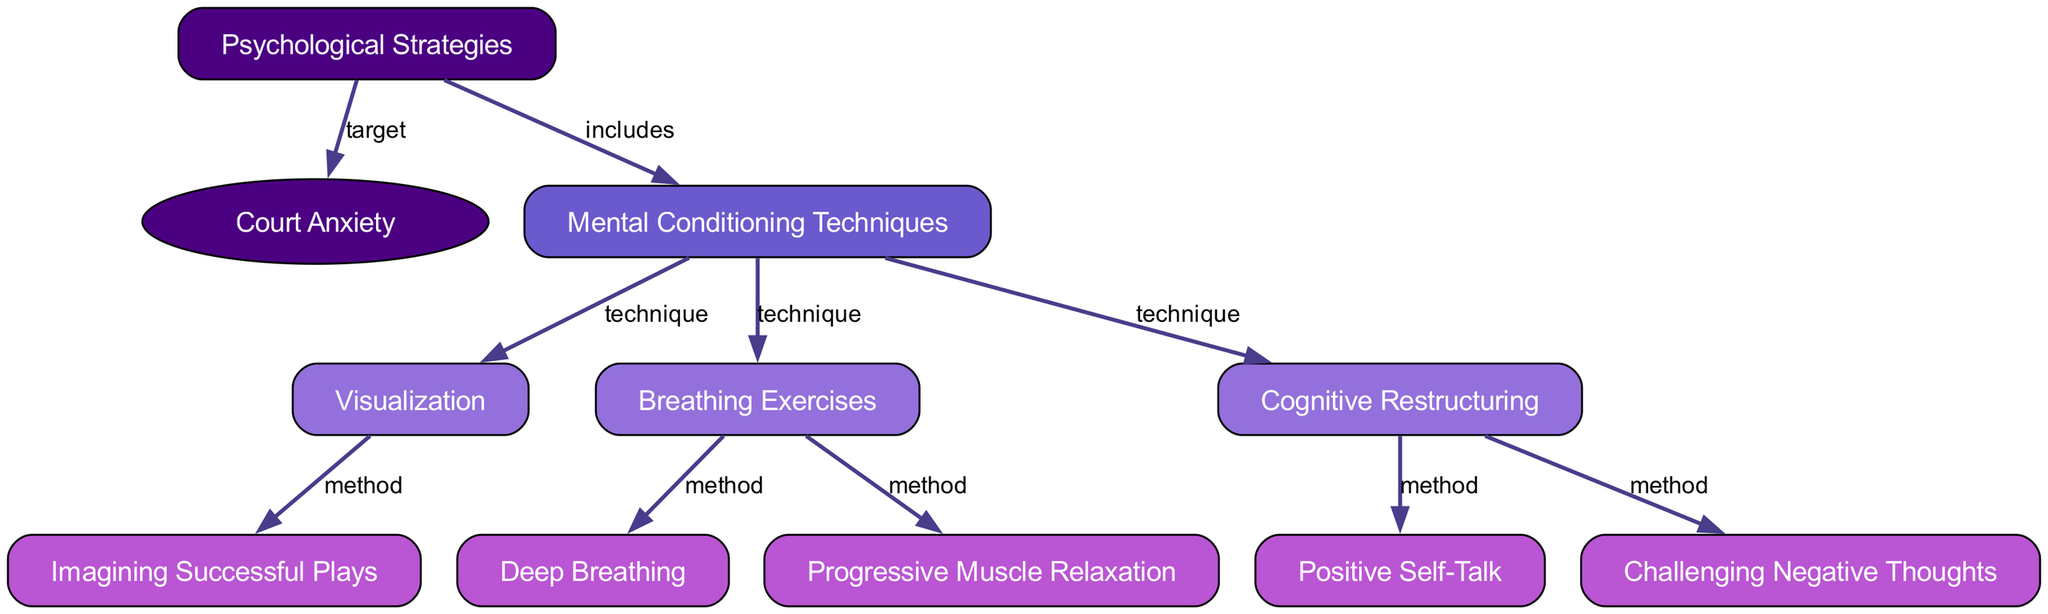What are the main psychological strategies presented in the diagram? The diagram includes one main node labeled "Psychological Strategies," which targets "Court Anxiety." This node is linked to various techniques that help address the anxiety players experience on the court.
Answer: Psychological Strategies How many mental conditioning techniques are listed in the diagram? The "Mental Conditioning Techniques" node includes three techniques connected to it, which are "Visualization," "Breathing Exercises," and "Cognitive Restructuring."
Answer: 3 What type of node is "Court Anxiety"? In the diagram, "Court Anxiety" is represented as an oval shape, indicating it is classified differently from the rectangular nodes which represent strategies and techniques.
Answer: Ellipse Which technique is associated with "Cognitive Restructuring"? Examining the edges connected to the "Cognitive Restructuring" node, we see it connects to "Positive Self-Talk" and "Challenging Negative Thoughts." Thus, these are the techniques associated with it.
Answer: Positive Self-Talk, Challenging Negative Thoughts What relationship exists between "Breathing Exercises" and its methods? The diagram shows that "Breathing Exercises" connects to two specific methods, which are "Deep Breathing" and "Progressive Muscle Relaxation." These methods help facilitate the main technique of breathing exercises.
Answer: Deep Breathing, Progressive Muscle Relaxation How does visualization relate to method execution? The "Visualization" technique is linked to a method called "Imagining Successful Plays," indicating that visualization directly facilitates the mental imagery of performing well during matches, which aids in overcoming anxiety.
Answer: Imagining Successful Plays Which psychological strategy is categorized as a response to cognitive challenges? The "Cognitive Restructuring" technique addresses cognitive challenges by emphasizing methods that involve altering thought patterns, specifically "Positive Self-Talk" and "Challenging Negative Thoughts."
Answer: Cognitive Restructuring How many edges connect to the "Mental Conditioning Techniques" node? The node "Mental Conditioning Techniques" connects to three edges, corresponding to the three different techniques indicated in the diagram. This helps visualize how various techniques target the issue of court anxiety.
Answer: 3 What color represents the techniques in the diagram? The diagram uses a shade labeled "Medium Purple" to fill color the nodes representing techniques. This color coding visually differentiates techniques from strategies and methods.
Answer: Medium Purple 